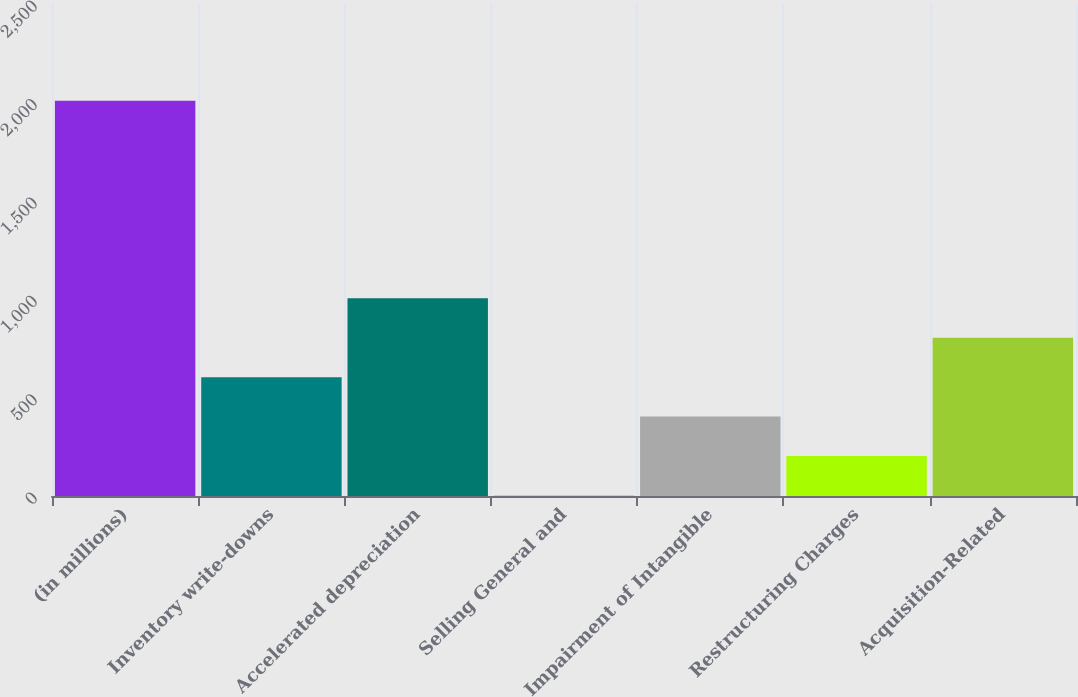<chart> <loc_0><loc_0><loc_500><loc_500><bar_chart><fcel>(in millions)<fcel>Inventory write-downs<fcel>Accelerated depreciation<fcel>Selling General and<fcel>Impairment of Intangible<fcel>Restructuring Charges<fcel>Acquisition-Related<nl><fcel>2008<fcel>603.94<fcel>1005.1<fcel>2.2<fcel>403.36<fcel>202.78<fcel>804.52<nl></chart> 